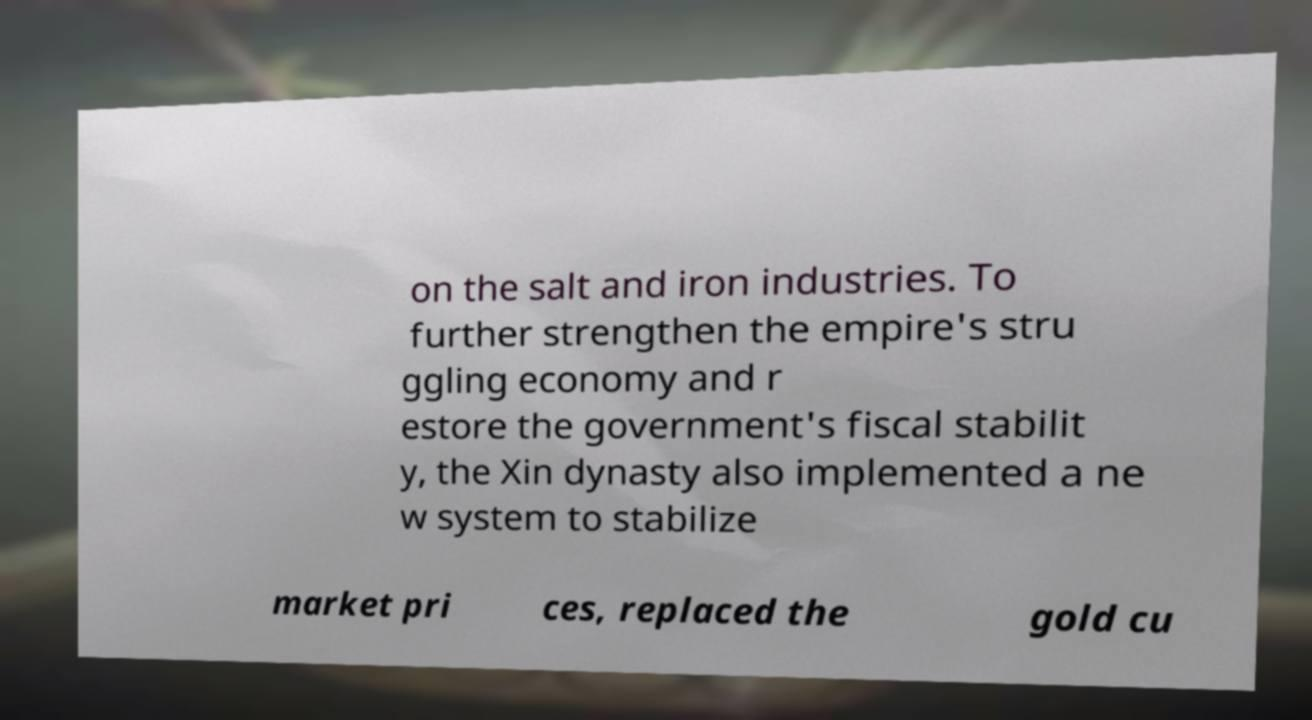For documentation purposes, I need the text within this image transcribed. Could you provide that? on the salt and iron industries. To further strengthen the empire's stru ggling economy and r estore the government's fiscal stabilit y, the Xin dynasty also implemented a ne w system to stabilize market pri ces, replaced the gold cu 